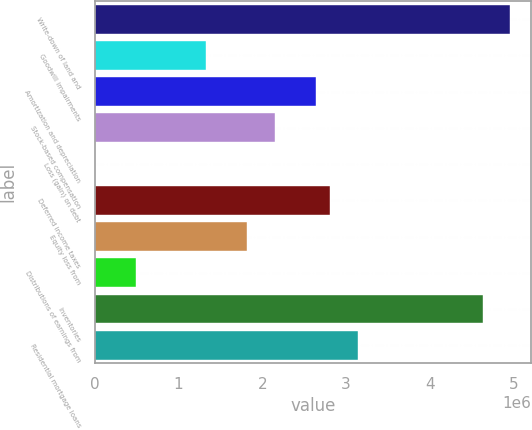<chart> <loc_0><loc_0><loc_500><loc_500><bar_chart><fcel>Write-down of land and<fcel>Goodwill impairments<fcel>Amortization and depreciation<fcel>Stock-based compensation<fcel>Loss (gain) on debt<fcel>Deferred income taxes<fcel>Equity loss from<fcel>Distributions of earnings from<fcel>Inventories<fcel>Residential mortgage loans<nl><fcel>4.9626e+06<fcel>1.32453e+06<fcel>2.64747e+06<fcel>2.15136e+06<fcel>1594<fcel>2.81283e+06<fcel>1.82063e+06<fcel>497695<fcel>4.63187e+06<fcel>3.14357e+06<nl></chart> 